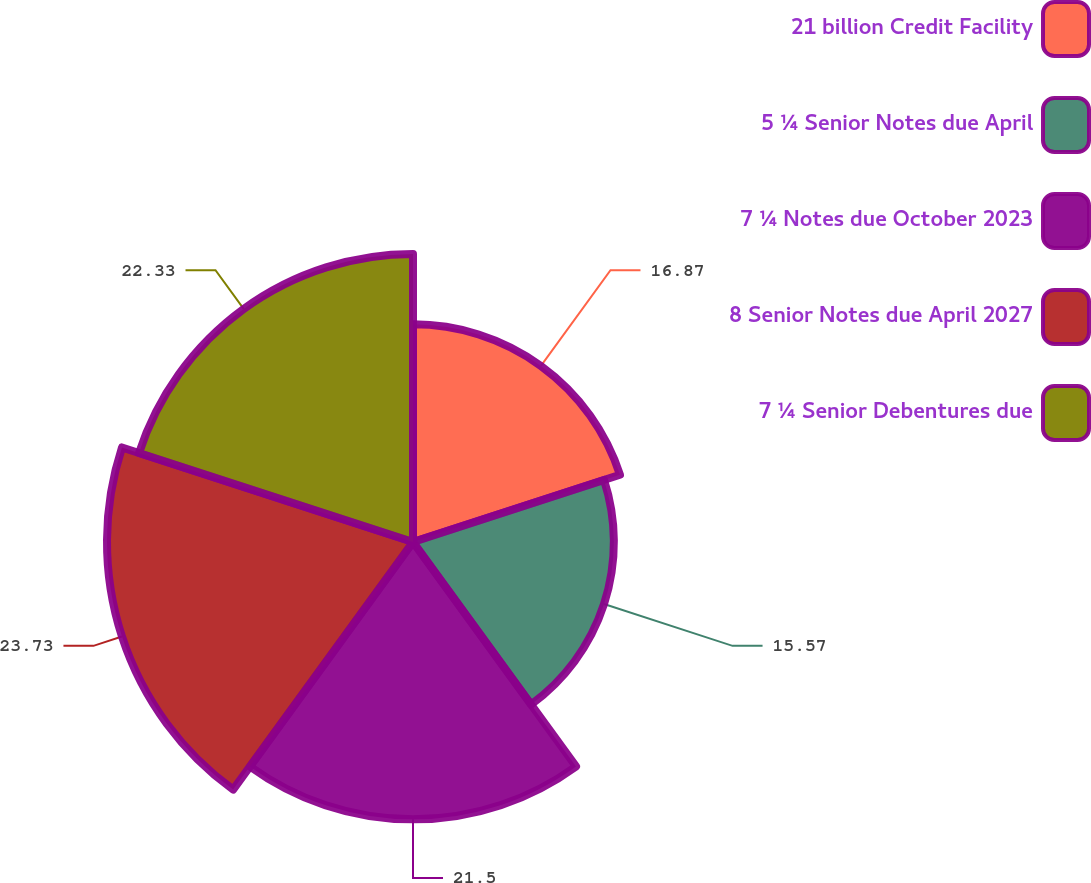<chart> <loc_0><loc_0><loc_500><loc_500><pie_chart><fcel>21 billion Credit Facility<fcel>5 ¼ Senior Notes due April<fcel>7 ¼ Notes due October 2023<fcel>8 Senior Notes due April 2027<fcel>7 ¼ Senior Debentures due<nl><fcel>16.87%<fcel>15.57%<fcel>21.5%<fcel>23.72%<fcel>22.33%<nl></chart> 